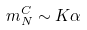<formula> <loc_0><loc_0><loc_500><loc_500>m _ { N } ^ { C } \sim K \alpha</formula> 